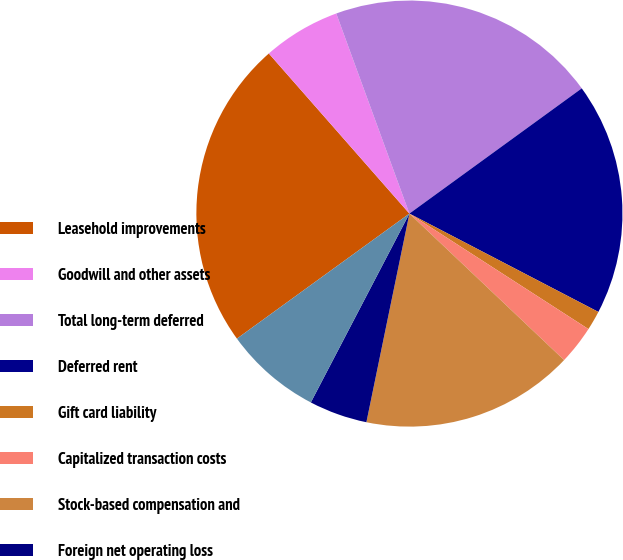Convert chart to OTSL. <chart><loc_0><loc_0><loc_500><loc_500><pie_chart><fcel>Leasehold improvements<fcel>Goodwill and other assets<fcel>Total long-term deferred<fcel>Deferred rent<fcel>Gift card liability<fcel>Capitalized transaction costs<fcel>Stock-based compensation and<fcel>Foreign net operating loss<fcel>Valuation allowance<nl><fcel>23.52%<fcel>5.89%<fcel>20.58%<fcel>17.64%<fcel>1.48%<fcel>2.95%<fcel>16.17%<fcel>4.42%<fcel>7.36%<nl></chart> 